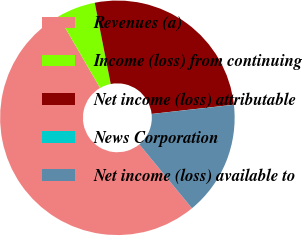<chart> <loc_0><loc_0><loc_500><loc_500><pie_chart><fcel>Revenues (a)<fcel>Income (loss) from continuing<fcel>Net income (loss) attributable<fcel>News Corporation<fcel>Net income (loss) available to<nl><fcel>52.61%<fcel>5.27%<fcel>26.31%<fcel>0.02%<fcel>15.79%<nl></chart> 